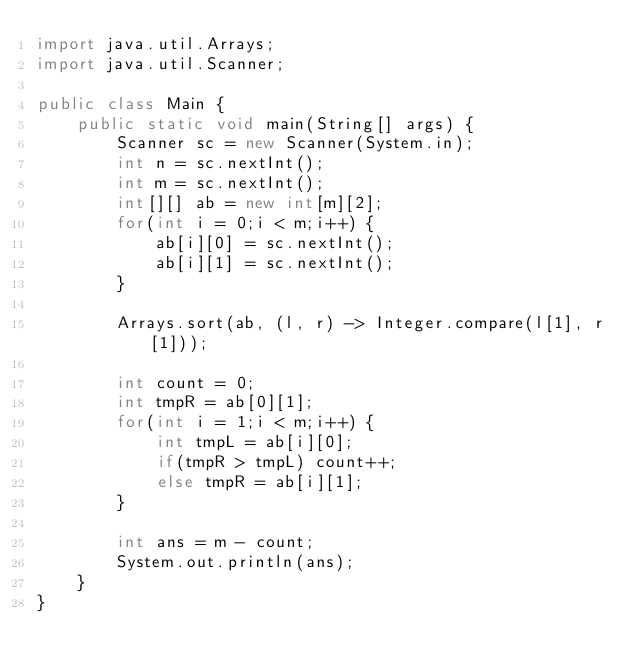Convert code to text. <code><loc_0><loc_0><loc_500><loc_500><_Java_>import java.util.Arrays;
import java.util.Scanner;

public class Main {
    public static void main(String[] args) {
        Scanner sc = new Scanner(System.in);
        int n = sc.nextInt();
        int m = sc.nextInt();
        int[][] ab = new int[m][2];
        for(int i = 0;i < m;i++) {
            ab[i][0] = sc.nextInt();
            ab[i][1] = sc.nextInt();
        }

        Arrays.sort(ab, (l, r) -> Integer.compare(l[1], r[1]));

        int count = 0;
        int tmpR = ab[0][1];
        for(int i = 1;i < m;i++) {
            int tmpL = ab[i][0];
            if(tmpR > tmpL) count++;
            else tmpR = ab[i][1];
        }

        int ans = m - count;
        System.out.println(ans);
    }
}
</code> 